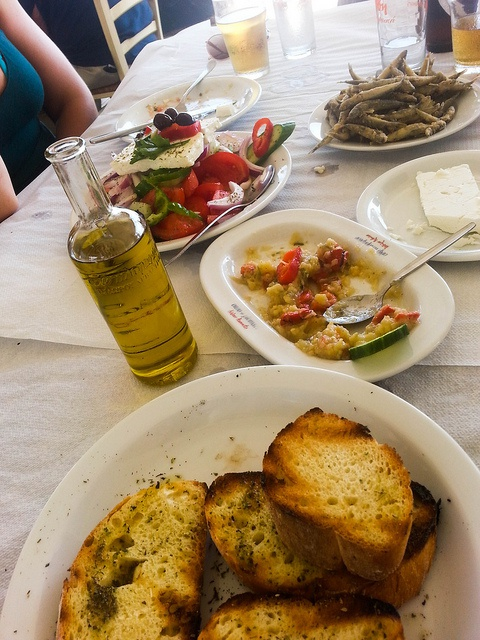Describe the objects in this image and their specific colors. I can see dining table in lightgray, tan, pink, and olive tones, bowl in pink, olive, tan, maroon, and black tones, bowl in pink, tan, and olive tones, bottle in pink, olive, maroon, and darkgray tones, and people in pink, black, maroon, brown, and lightgray tones in this image. 